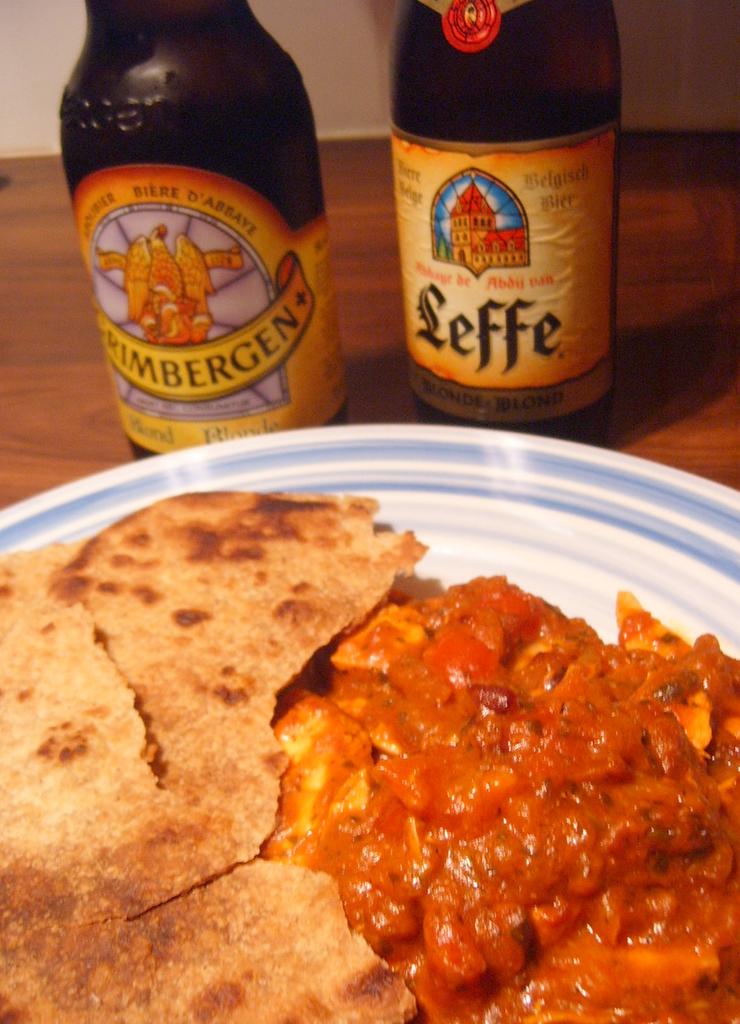What is the brand of beer in the background?
Your answer should be very brief. Leffe. 